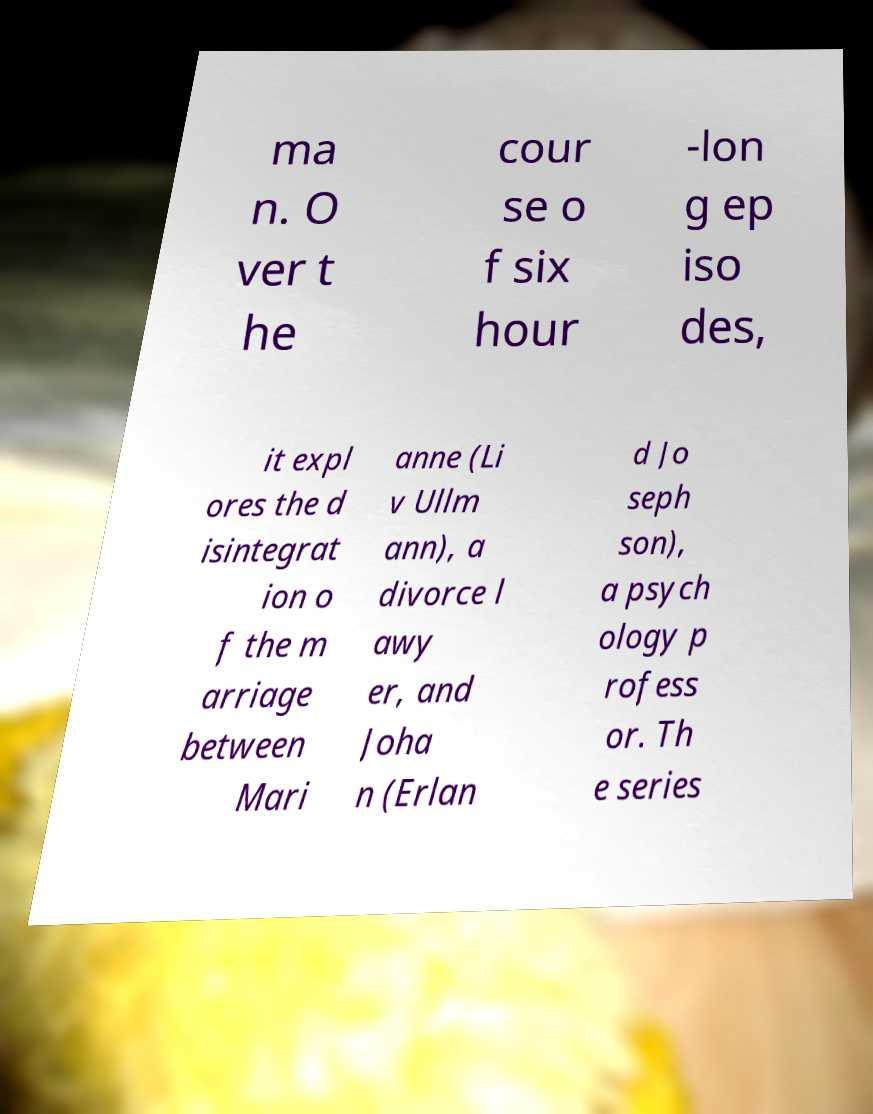Please read and relay the text visible in this image. What does it say? ma n. O ver t he cour se o f six hour -lon g ep iso des, it expl ores the d isintegrat ion o f the m arriage between Mari anne (Li v Ullm ann), a divorce l awy er, and Joha n (Erlan d Jo seph son), a psych ology p rofess or. Th e series 